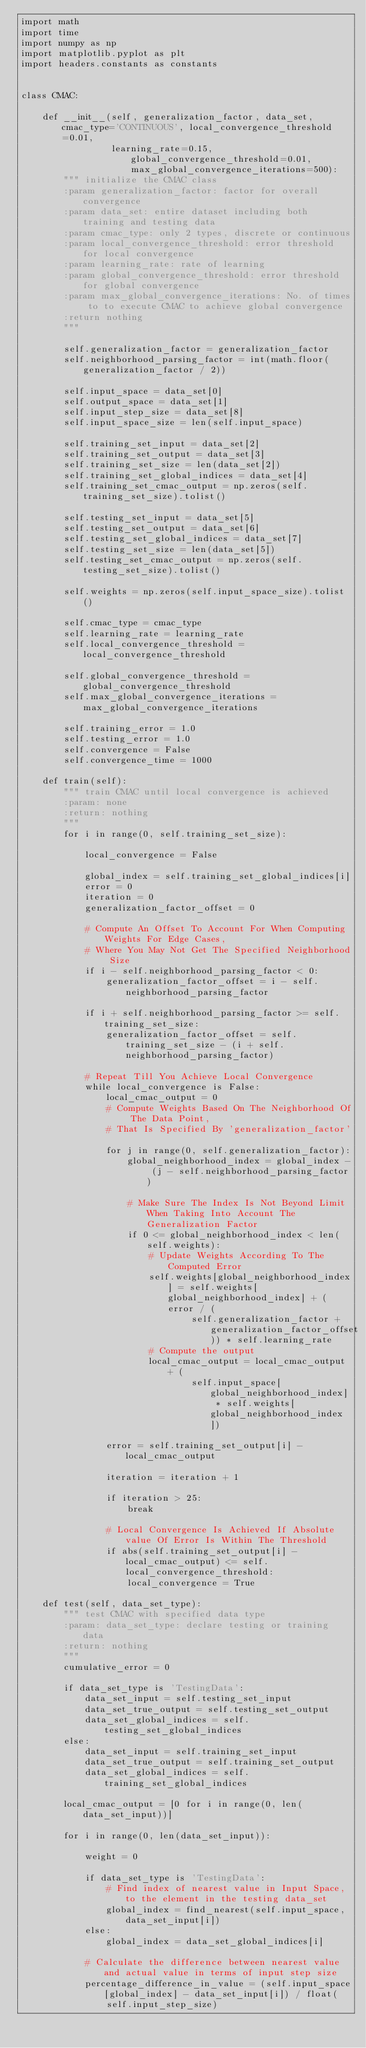<code> <loc_0><loc_0><loc_500><loc_500><_Python_>import math
import time
import numpy as np
import matplotlib.pyplot as plt
import headers.constants as constants


class CMAC:

    def __init__(self, generalization_factor, data_set, cmac_type='CONTINUOUS', local_convergence_threshold=0.01,
                 learning_rate=0.15, global_convergence_threshold=0.01, max_global_convergence_iterations=500):
        """ initialize the CMAC class
        :param generalization_factor: factor for overall convergence
        :param data_set: entire dataset including both training and testing data
        :param cmac_type: only 2 types, discrete or continuous
        :param local_convergence_threshold: error threshold for local convergence
        :param learning_rate: rate of learning
        :param global_convergence_threshold: error threshold for global convergence
        :param max_global_convergence_iterations: No. of times to to execute CMAC to achieve global convergence
        :return nothing
        """
        
        self.generalization_factor = generalization_factor
        self.neighborhood_parsing_factor = int(math.floor(generalization_factor / 2))

        self.input_space = data_set[0]
        self.output_space = data_set[1]
        self.input_step_size = data_set[8]
        self.input_space_size = len(self.input_space)

        self.training_set_input = data_set[2]
        self.training_set_output = data_set[3]
        self.training_set_size = len(data_set[2])
        self.training_set_global_indices = data_set[4]
        self.training_set_cmac_output = np.zeros(self.training_set_size).tolist()

        self.testing_set_input = data_set[5]
        self.testing_set_output = data_set[6]
        self.testing_set_global_indices = data_set[7]
        self.testing_set_size = len(data_set[5])
        self.testing_set_cmac_output = np.zeros(self.testing_set_size).tolist()

        self.weights = np.zeros(self.input_space_size).tolist()

        self.cmac_type = cmac_type
        self.learning_rate = learning_rate
        self.local_convergence_threshold = local_convergence_threshold

        self.global_convergence_threshold = global_convergence_threshold
        self.max_global_convergence_iterations = max_global_convergence_iterations

        self.training_error = 1.0
        self.testing_error = 1.0
        self.convergence = False
        self.convergence_time = 1000

    def train(self):
        """ train CMAC until local convergence is achieved
        :param: none
        :return: nothing
        """
        for i in range(0, self.training_set_size):

            local_convergence = False

            global_index = self.training_set_global_indices[i]
            error = 0
            iteration = 0
            generalization_factor_offset = 0

            # Compute An Offset To Account For When Computing Weights For Edge Cases,
            # Where You May Not Get The Specified Neighborhood Size
            if i - self.neighborhood_parsing_factor < 0:
                generalization_factor_offset = i - self.neighborhood_parsing_factor

            if i + self.neighborhood_parsing_factor >= self.training_set_size:
                generalization_factor_offset = self.training_set_size - (i + self.neighborhood_parsing_factor)

            # Repeat Till You Achieve Local Convergence
            while local_convergence is False:
                local_cmac_output = 0
                # Compute Weights Based On The Neighborhood Of The Data Point, 
                # That Is Specified By 'generalization_factor'	
                for j in range(0, self.generalization_factor):
                    global_neighborhood_index = global_index - (j - self.neighborhood_parsing_factor)

                    # Make Sure The Index Is Not Beyond Limit When Taking Into Account The Generalization Factor
                    if 0 <= global_neighborhood_index < len(self.weights):
                        # Update Weights According To The Computed Error
                        self.weights[global_neighborhood_index] = self.weights[global_neighborhood_index] + (error / (
                                self.generalization_factor + generalization_factor_offset)) * self.learning_rate
                        # Compute the output
                        local_cmac_output = local_cmac_output + (
                                self.input_space[global_neighborhood_index] * self.weights[global_neighborhood_index])

                error = self.training_set_output[i] - local_cmac_output

                iteration = iteration + 1

                if iteration > 25:
                    break

                # Local Convergence Is Achieved If Absolute value Of Error Is Within The Threshold
                if abs(self.training_set_output[i] - local_cmac_output) <= self.local_convergence_threshold:
                    local_convergence = True

    def test(self, data_set_type):
        """ test CMAC with specified data type
        :param: data_set_type: declare testing or training data
        :return: nothing
        """
        cumulative_error = 0

        if data_set_type is 'TestingData':
            data_set_input = self.testing_set_input
            data_set_true_output = self.testing_set_output
            data_set_global_indices = self.testing_set_global_indices
        else:
            data_set_input = self.training_set_input
            data_set_true_output = self.training_set_output
            data_set_global_indices = self.training_set_global_indices

        local_cmac_output = [0 for i in range(0, len(data_set_input))]

        for i in range(0, len(data_set_input)):

            weight = 0

            if data_set_type is 'TestingData':
                # Find index of nearest value in Input Space, to the element in the testing data_set
                global_index = find_nearest(self.input_space, data_set_input[i])
            else:
                global_index = data_set_global_indices[i]

            # Calculate the difference between nearest value and actual value in terms of input step size
            percentage_difference_in_value = (self.input_space[global_index] - data_set_input[i]) / float(
                self.input_step_size)</code> 